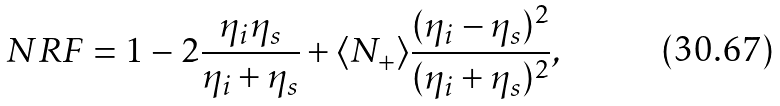<formula> <loc_0><loc_0><loc_500><loc_500>N R F = 1 - 2 \frac { \eta _ { i } \eta _ { s } } { \eta _ { i } + \eta _ { s } } + \langle N _ { + } \rangle \frac { ( \eta _ { i } - \eta _ { s } ) ^ { 2 } } { ( \eta _ { i } + \eta _ { s } ) ^ { 2 } } ,</formula> 